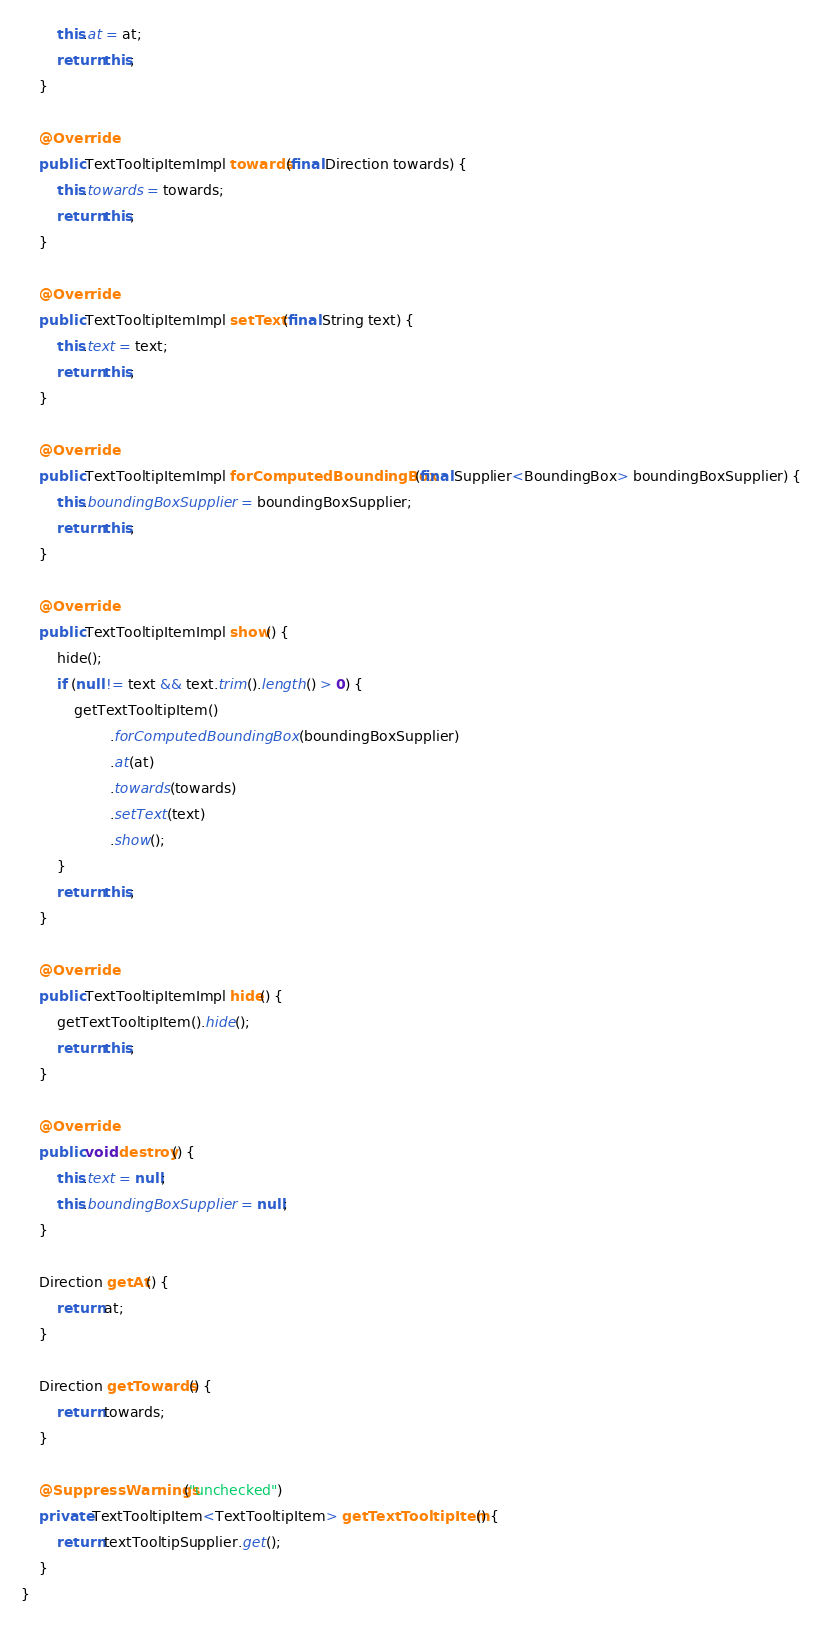Convert code to text. <code><loc_0><loc_0><loc_500><loc_500><_Java_>        this.at = at;
        return this;
    }

    @Override
    public TextTooltipItemImpl towards(final Direction towards) {
        this.towards = towards;
        return this;
    }

    @Override
    public TextTooltipItemImpl setText(final String text) {
        this.text = text;
        return this;
    }

    @Override
    public TextTooltipItemImpl forComputedBoundingBox(final Supplier<BoundingBox> boundingBoxSupplier) {
        this.boundingBoxSupplier = boundingBoxSupplier;
        return this;
    }

    @Override
    public TextTooltipItemImpl show() {
        hide();
        if (null != text && text.trim().length() > 0) {
            getTextTooltipItem()
                    .forComputedBoundingBox(boundingBoxSupplier)
                    .at(at)
                    .towards(towards)
                    .setText(text)
                    .show();
        }
        return this;
    }

    @Override
    public TextTooltipItemImpl hide() {
        getTextTooltipItem().hide();
        return this;
    }

    @Override
    public void destroy() {
        this.text = null;
        this.boundingBoxSupplier = null;
    }

    Direction getAt() {
        return at;
    }

    Direction getTowards() {
        return towards;
    }

    @SuppressWarnings("unchecked")
    private TextTooltipItem<TextTooltipItem> getTextTooltipItem() {
        return textTooltipSupplier.get();
    }
}
</code> 